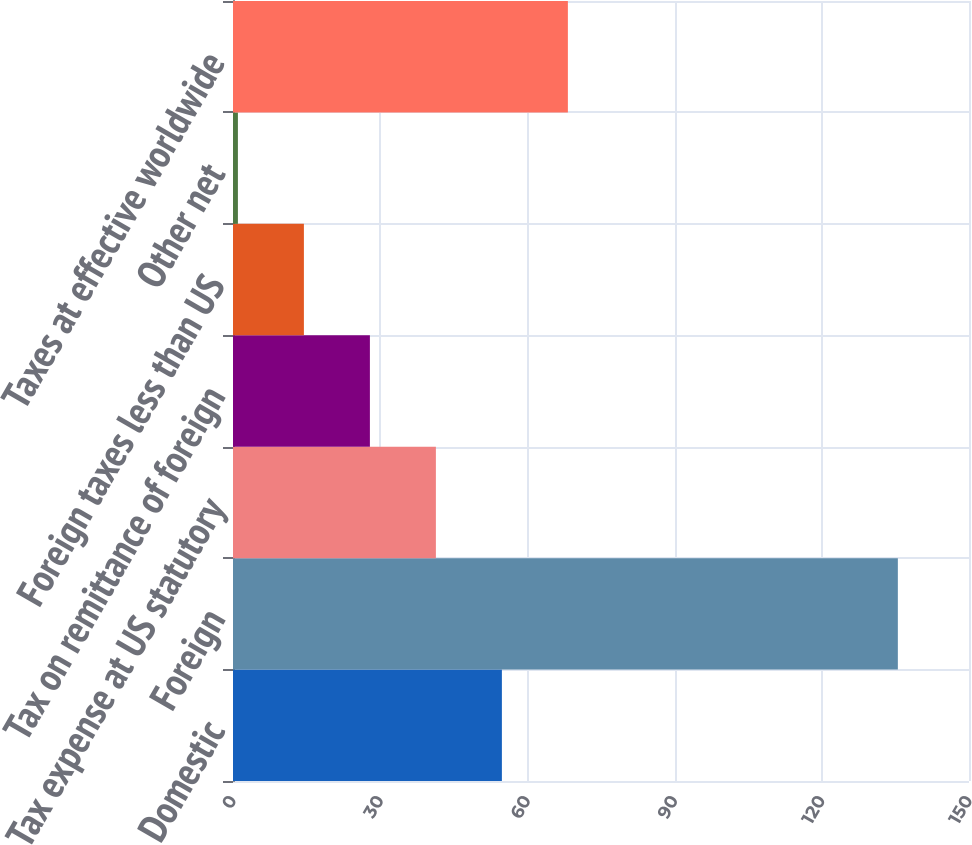Convert chart. <chart><loc_0><loc_0><loc_500><loc_500><bar_chart><fcel>Domestic<fcel>Foreign<fcel>Tax expense at US statutory<fcel>Tax on remittance of foreign<fcel>Foreign taxes less than US<fcel>Other net<fcel>Taxes at effective worldwide<nl><fcel>54.8<fcel>135.5<fcel>41.35<fcel>27.9<fcel>14.45<fcel>1<fcel>68.25<nl></chart> 